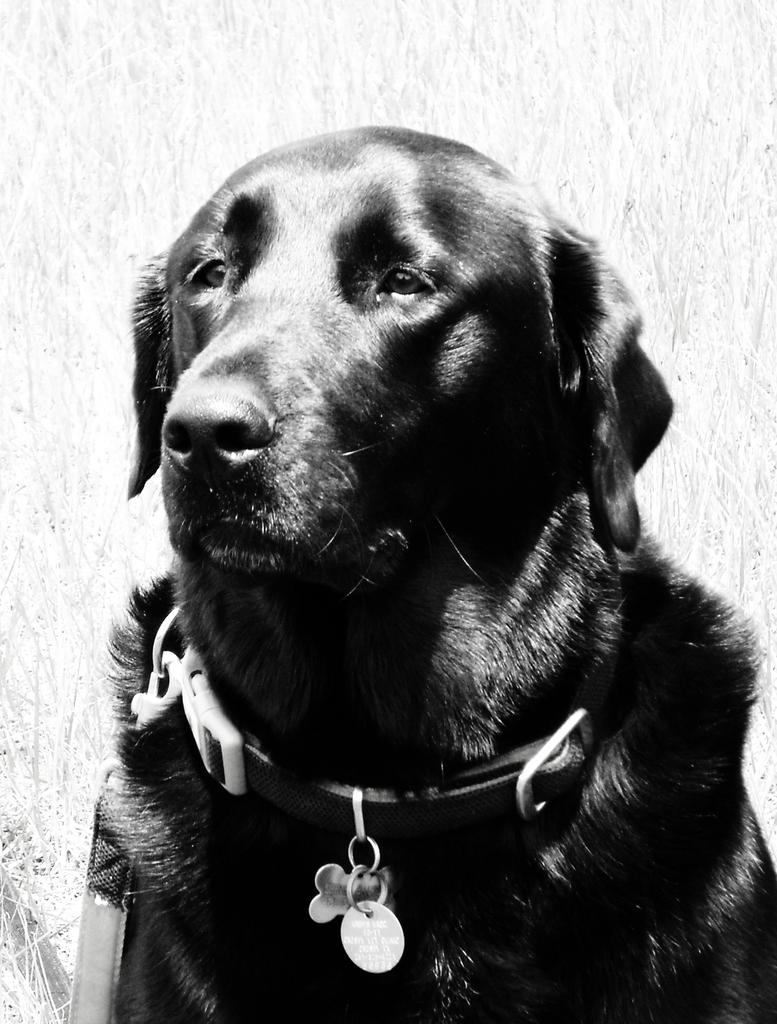What is the color scheme of the image? The image is black and white. What type of animal can be seen in the image? There is a black dog in the image. Is there any accessory or object attached to the dog? Yes, a belt is tied to the dog's neck. What type of book is the dog holding in the image? There is no book present in the image; it features a black dog with a belt tied to its neck. How does the wind affect the dog's movement in the image? There is no wind present in the image, and therefore no effect on the dog's movement can be observed. 